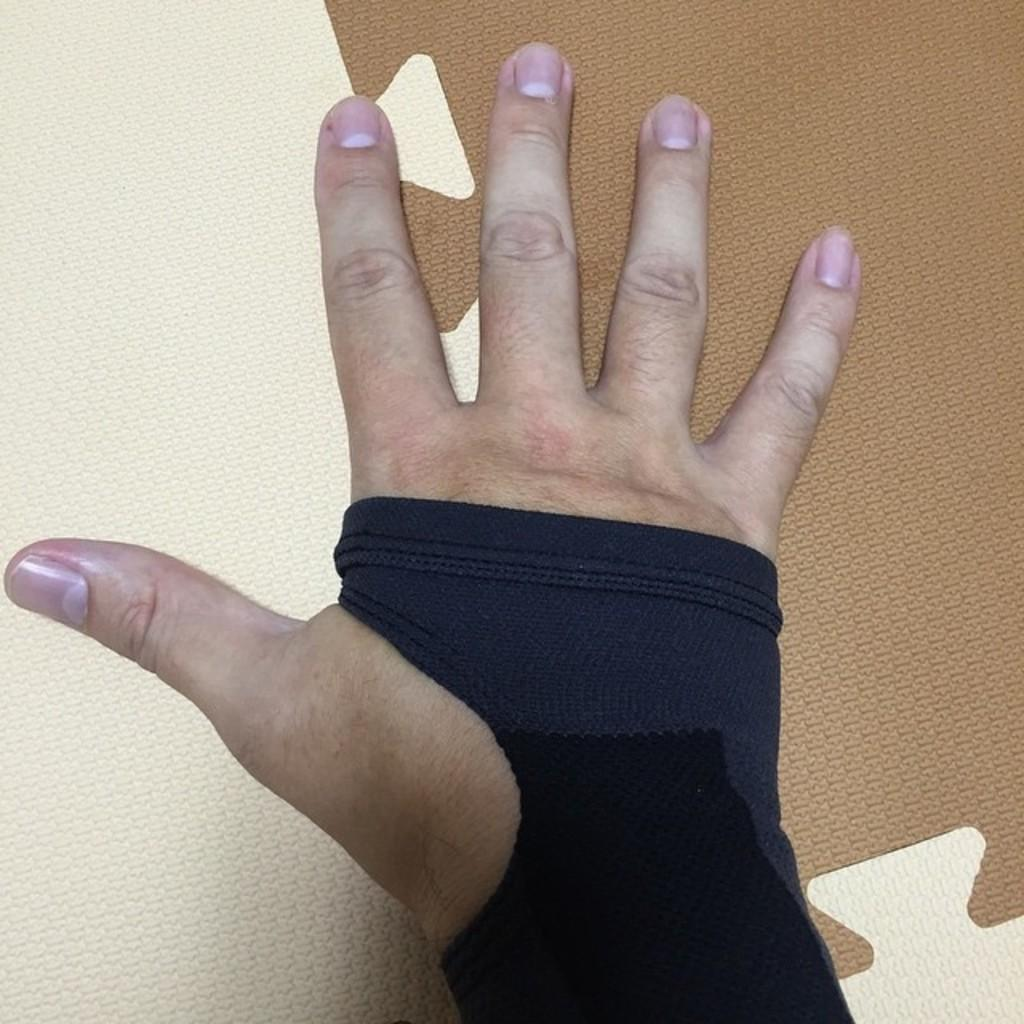What is the main subject of the image? The main subject of the image is a hand. What is the hand wearing? The hand is wearing a black glove. What can be seen in the background of the image? There is a wall in the background of the image. What type of teaching is the hand demonstrating in the image? There is no teaching or demonstration present in the image; it only features a hand wearing a black glove with a wall in the background. 